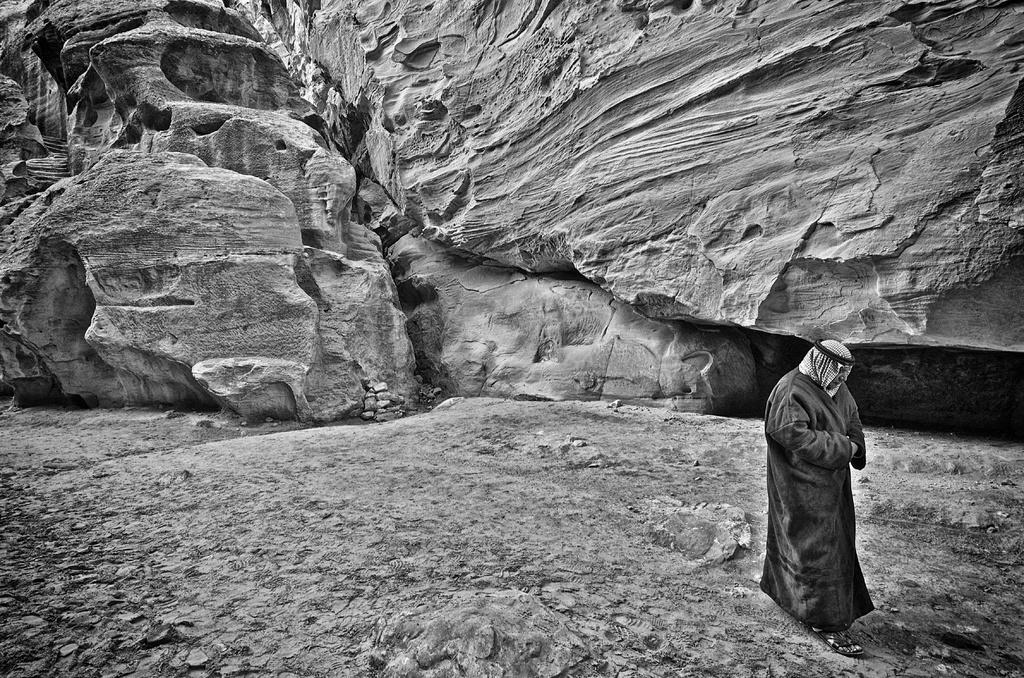Who is present in the image? There is a man in the picture. What is the man doing in the image? The man is walking. What is the man wearing in the image? The man is wearing a black coat. What can be seen in the background of the image? There are rocks and mountains in the backdrop of the image. What type of chin can be seen on the toy in the image? There is no toy present in the image, and therefore no chin can be observed. Is there any eggnog visible in the image? There is no eggnog present in the image. 